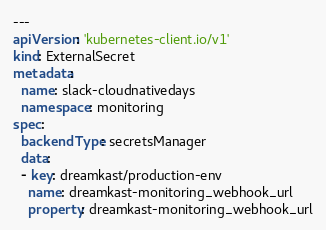<code> <loc_0><loc_0><loc_500><loc_500><_YAML_>---
apiVersion: 'kubernetes-client.io/v1'
kind: ExternalSecret
metadata:
  name: slack-cloudnativedays
  namespace: monitoring
spec:
  backendType: secretsManager
  data:
  - key: dreamkast/production-env
    name: dreamkast-monitoring_webhook_url
    property: dreamkast-monitoring_webhook_url
</code> 